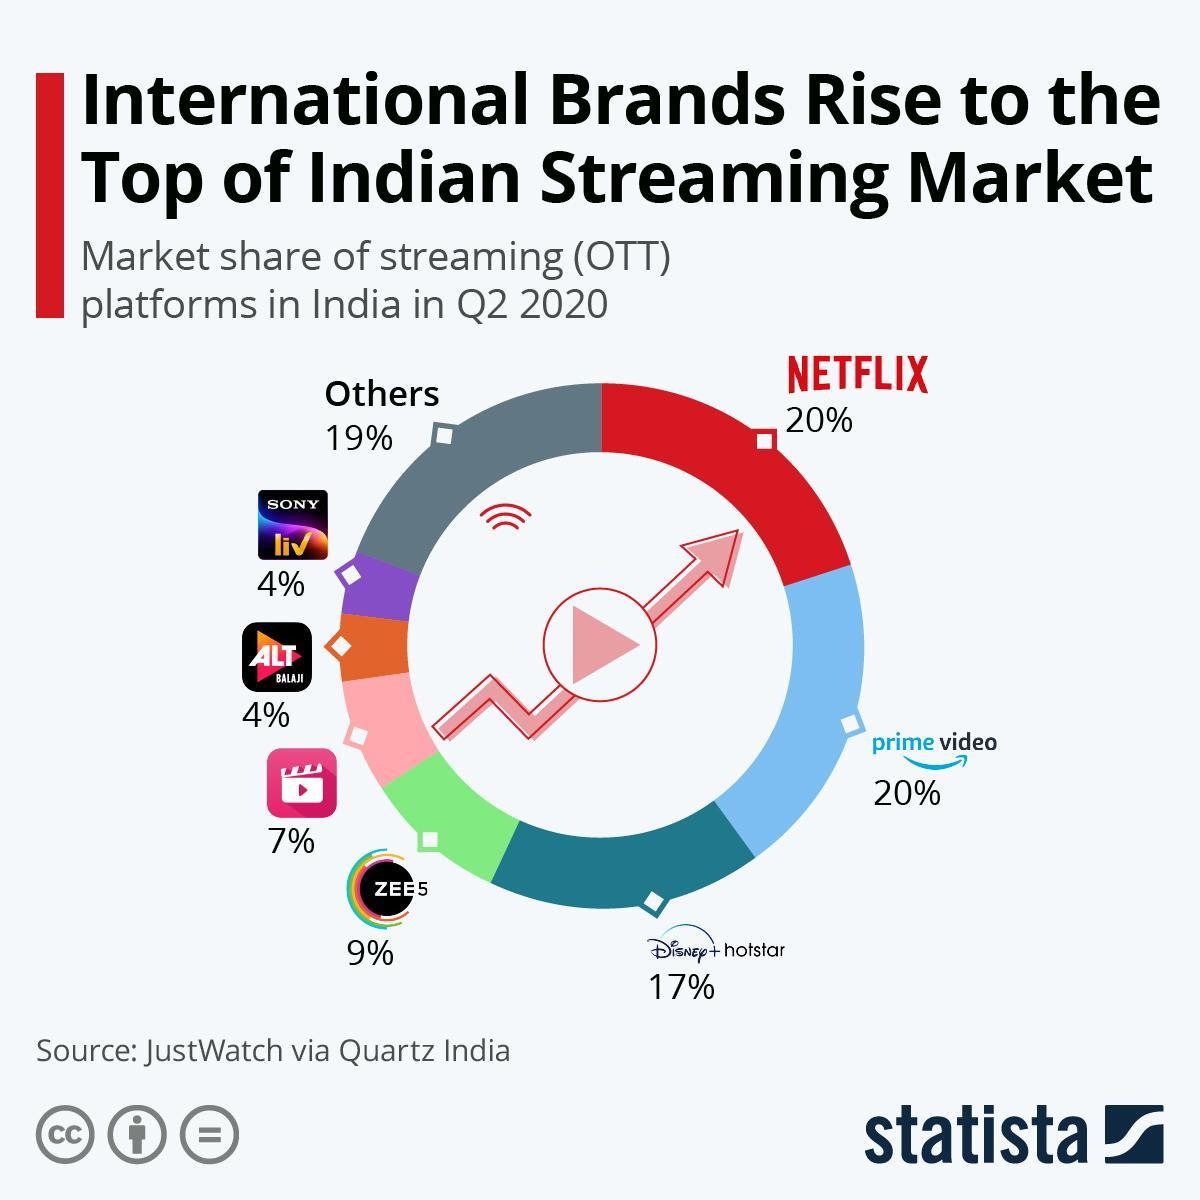What is the market share of ZEE5 in India in Q2 2020?
Answer the question with a short phrase. 9% Which OTT platform has the highest market share in India in Q2 2020? NETFLIX What is the market share of Disney+ hotstar in India in Q2 2020? 17% Which OTT platform has the second highest market share in India in Q2 2020? prime video 